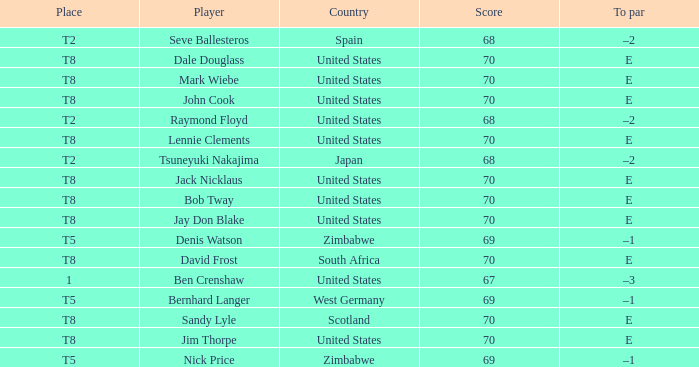What player has The United States as the country, with t2 as the place? Raymond Floyd. 